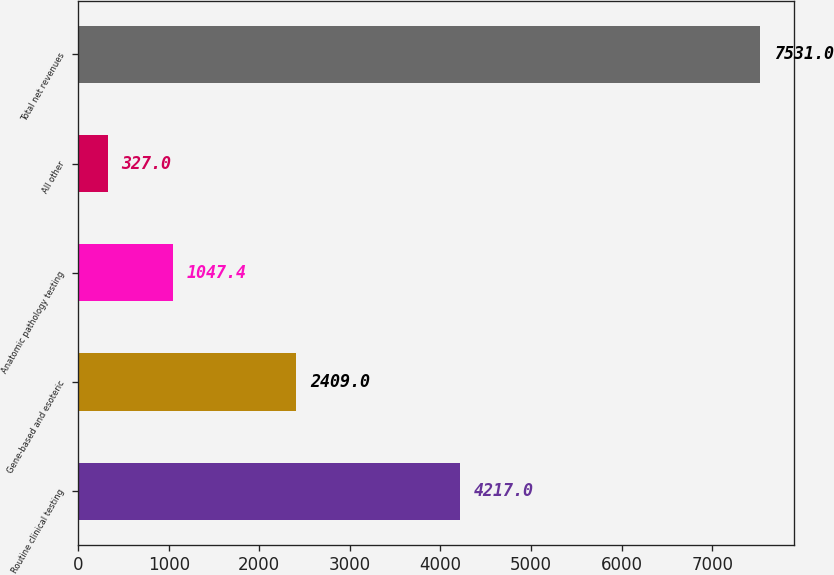Convert chart. <chart><loc_0><loc_0><loc_500><loc_500><bar_chart><fcel>Routine clinical testing<fcel>Gene-based and esoteric<fcel>Anatomic pathology testing<fcel>All other<fcel>Total net revenues<nl><fcel>4217<fcel>2409<fcel>1047.4<fcel>327<fcel>7531<nl></chart> 